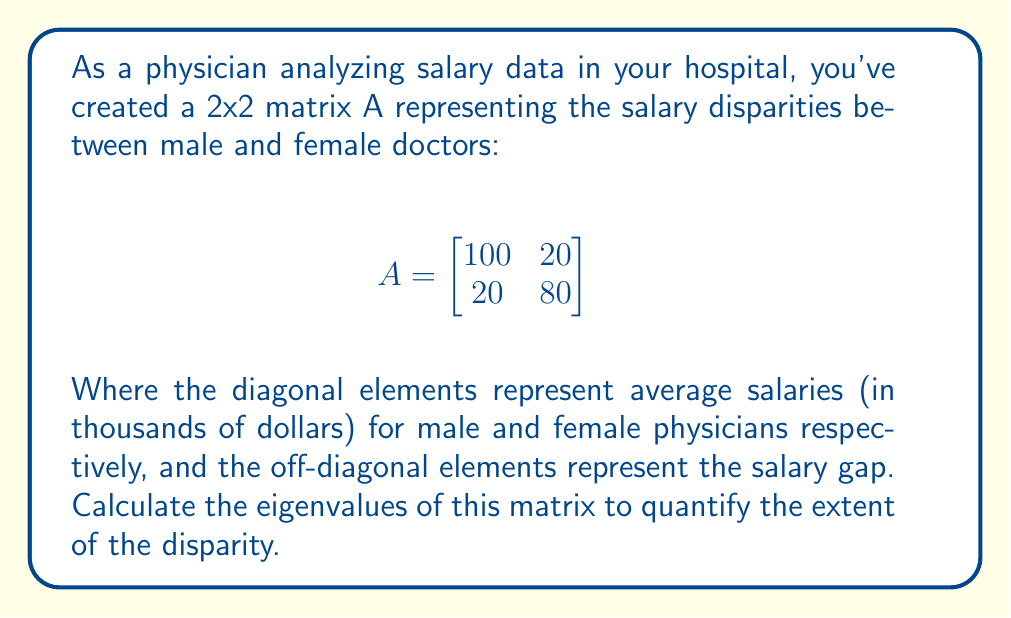Provide a solution to this math problem. To find the eigenvalues of matrix A, we need to solve the characteristic equation:

1) First, we set up the equation: $det(A - \lambda I) = 0$

2) Expand this equation:
   $$det\begin{bmatrix}
   100-\lambda & 20 \\
   20 & 80-\lambda
   \end{bmatrix} = 0$$

3) Calculate the determinant:
   $(100-\lambda)(80-\lambda) - 20 \cdot 20 = 0$

4) Expand the equation:
   $8000 - 180\lambda + \lambda^2 - 400 = 0$

5) Simplify:
   $\lambda^2 - 180\lambda + 7600 = 0$

6) This is a quadratic equation. We can solve it using the quadratic formula:
   $\lambda = \frac{-b \pm \sqrt{b^2 - 4ac}}{2a}$

   Where $a=1$, $b=-180$, and $c=7600$

7) Substitute these values:
   $\lambda = \frac{180 \pm \sqrt{180^2 - 4(1)(7600)}}{2(1)}$

8) Simplify:
   $\lambda = \frac{180 \pm \sqrt{32400 - 30400}}{2} = \frac{180 \pm \sqrt{2000}}{2}$

9) Calculate the final values:
   $\lambda_1 = \frac{180 + \sqrt{2000}}{2} \approx 112.4$
   $\lambda_2 = \frac{180 - \sqrt{2000}}{2} \approx 67.6$
Answer: $\lambda_1 \approx 112.4$, $\lambda_2 \approx 67.6$ 